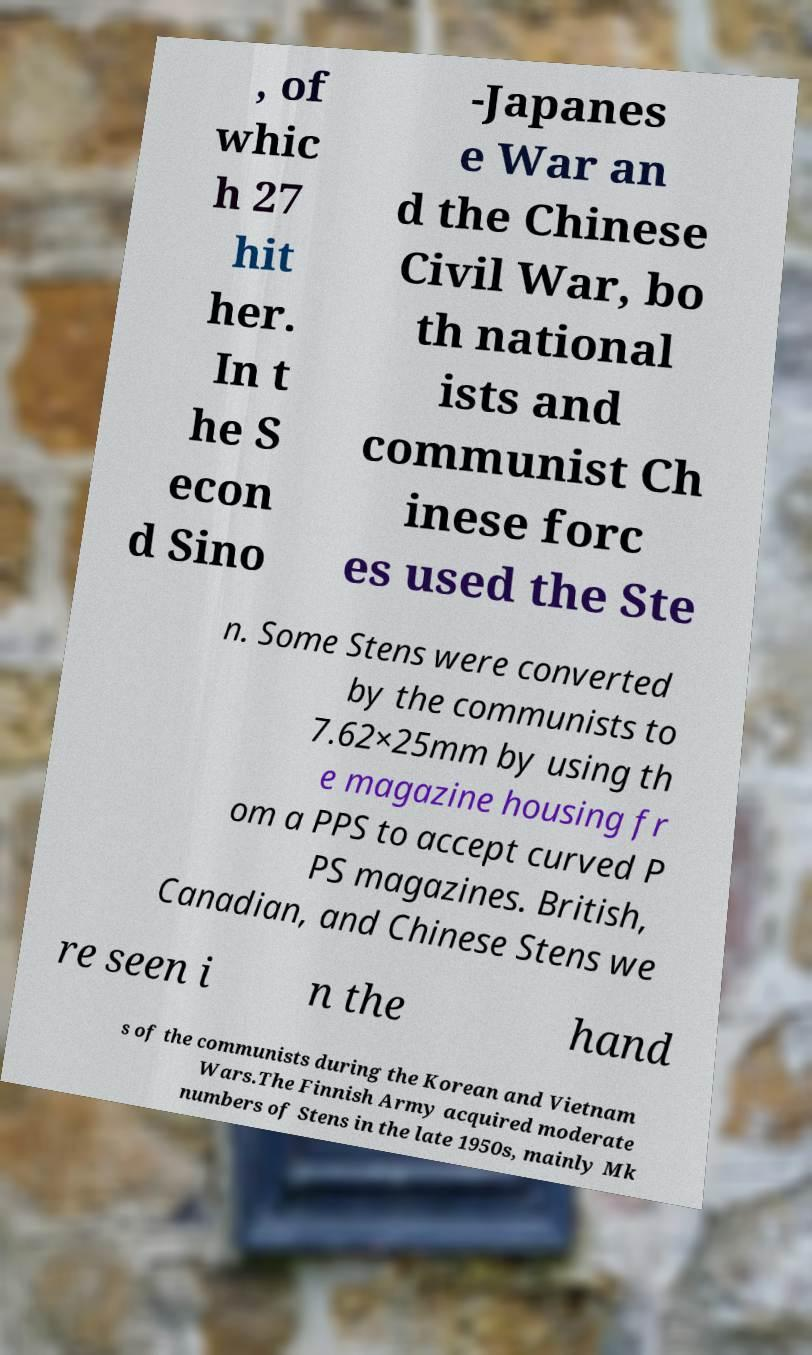Please read and relay the text visible in this image. What does it say? , of whic h 27 hit her. In t he S econ d Sino -Japanes e War an d the Chinese Civil War, bo th national ists and communist Ch inese forc es used the Ste n. Some Stens were converted by the communists to 7.62×25mm by using th e magazine housing fr om a PPS to accept curved P PS magazines. British, Canadian, and Chinese Stens we re seen i n the hand s of the communists during the Korean and Vietnam Wars.The Finnish Army acquired moderate numbers of Stens in the late 1950s, mainly Mk 